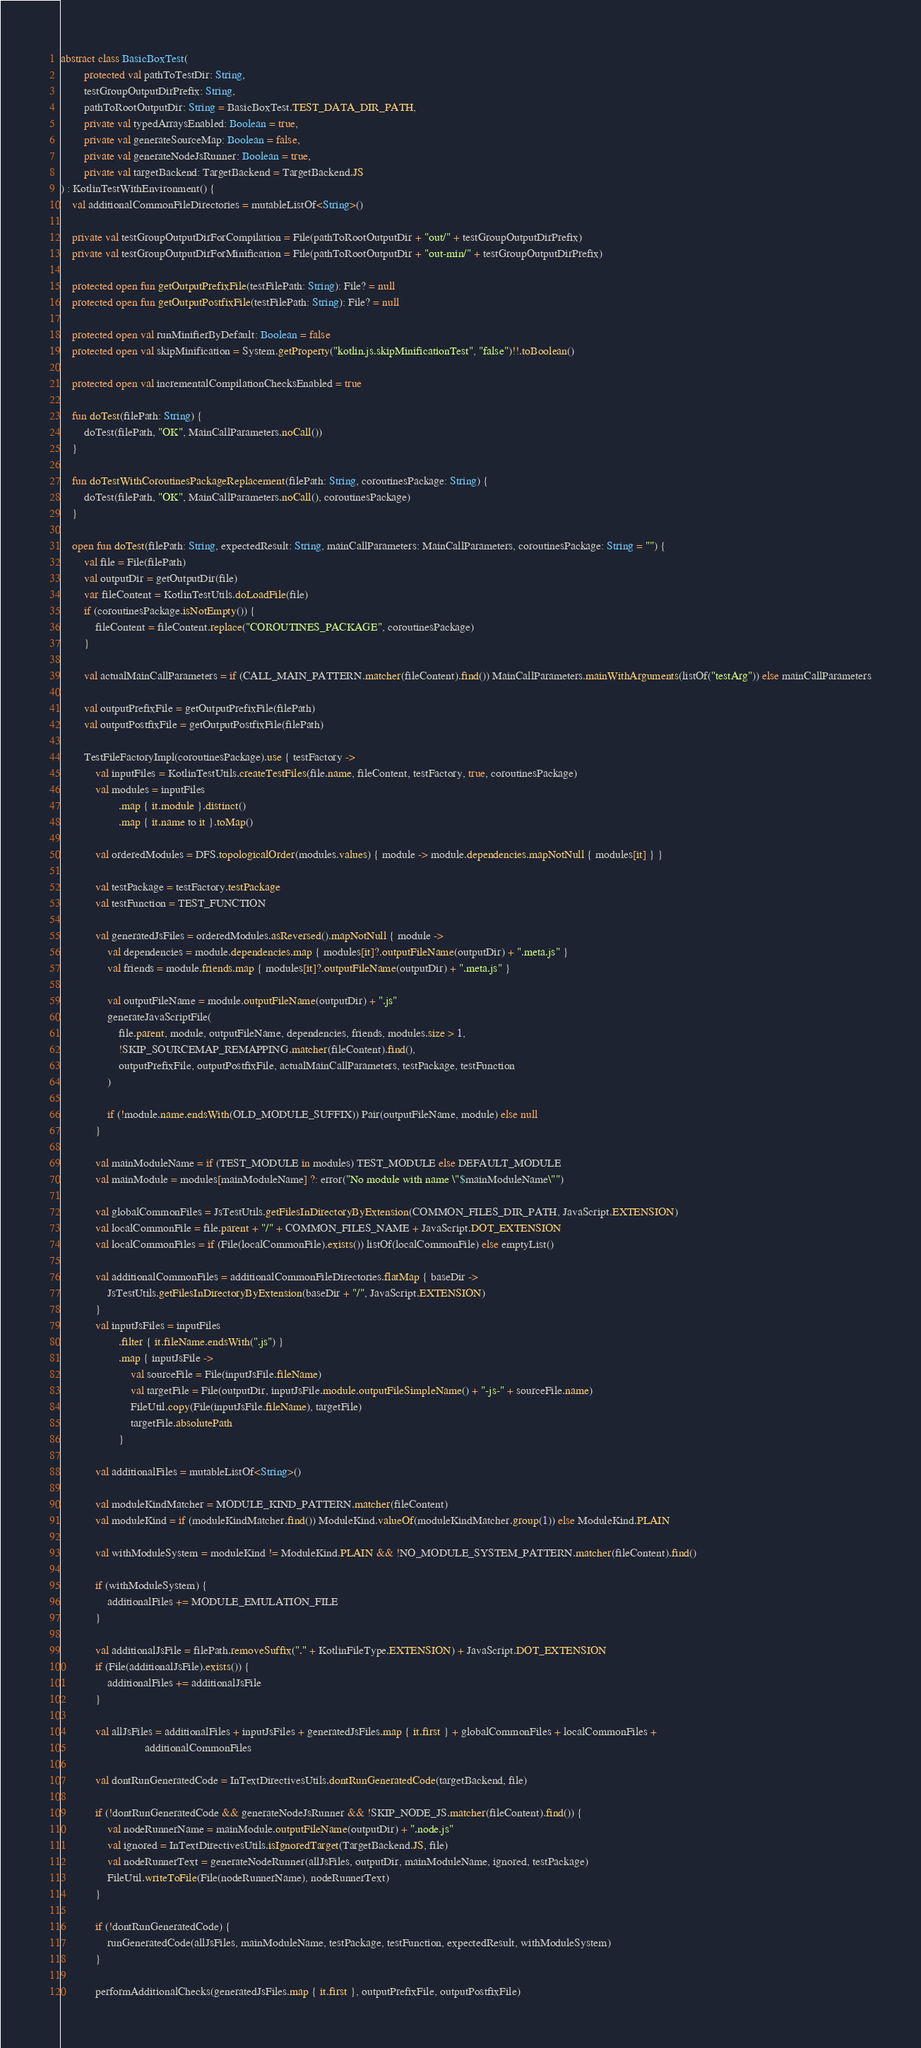Convert code to text. <code><loc_0><loc_0><loc_500><loc_500><_Kotlin_>abstract class BasicBoxTest(
        protected val pathToTestDir: String,
        testGroupOutputDirPrefix: String,
        pathToRootOutputDir: String = BasicBoxTest.TEST_DATA_DIR_PATH,
        private val typedArraysEnabled: Boolean = true,
        private val generateSourceMap: Boolean = false,
        private val generateNodeJsRunner: Boolean = true,
        private val targetBackend: TargetBackend = TargetBackend.JS
) : KotlinTestWithEnvironment() {
    val additionalCommonFileDirectories = mutableListOf<String>()

    private val testGroupOutputDirForCompilation = File(pathToRootOutputDir + "out/" + testGroupOutputDirPrefix)
    private val testGroupOutputDirForMinification = File(pathToRootOutputDir + "out-min/" + testGroupOutputDirPrefix)

    protected open fun getOutputPrefixFile(testFilePath: String): File? = null
    protected open fun getOutputPostfixFile(testFilePath: String): File? = null

    protected open val runMinifierByDefault: Boolean = false
    protected open val skipMinification = System.getProperty("kotlin.js.skipMinificationTest", "false")!!.toBoolean()

    protected open val incrementalCompilationChecksEnabled = true

    fun doTest(filePath: String) {
        doTest(filePath, "OK", MainCallParameters.noCall())
    }

    fun doTestWithCoroutinesPackageReplacement(filePath: String, coroutinesPackage: String) {
        doTest(filePath, "OK", MainCallParameters.noCall(), coroutinesPackage)
    }

    open fun doTest(filePath: String, expectedResult: String, mainCallParameters: MainCallParameters, coroutinesPackage: String = "") {
        val file = File(filePath)
        val outputDir = getOutputDir(file)
        var fileContent = KotlinTestUtils.doLoadFile(file)
        if (coroutinesPackage.isNotEmpty()) {
            fileContent = fileContent.replace("COROUTINES_PACKAGE", coroutinesPackage)
        }

        val actualMainCallParameters = if (CALL_MAIN_PATTERN.matcher(fileContent).find()) MainCallParameters.mainWithArguments(listOf("testArg")) else mainCallParameters

        val outputPrefixFile = getOutputPrefixFile(filePath)
        val outputPostfixFile = getOutputPostfixFile(filePath)

        TestFileFactoryImpl(coroutinesPackage).use { testFactory ->
            val inputFiles = KotlinTestUtils.createTestFiles(file.name, fileContent, testFactory, true, coroutinesPackage)
            val modules = inputFiles
                    .map { it.module }.distinct()
                    .map { it.name to it }.toMap()

            val orderedModules = DFS.topologicalOrder(modules.values) { module -> module.dependencies.mapNotNull { modules[it] } }

            val testPackage = testFactory.testPackage
            val testFunction = TEST_FUNCTION

            val generatedJsFiles = orderedModules.asReversed().mapNotNull { module ->
                val dependencies = module.dependencies.map { modules[it]?.outputFileName(outputDir) + ".meta.js" }
                val friends = module.friends.map { modules[it]?.outputFileName(outputDir) + ".meta.js" }

                val outputFileName = module.outputFileName(outputDir) + ".js"
                generateJavaScriptFile(
                    file.parent, module, outputFileName, dependencies, friends, modules.size > 1,
                    !SKIP_SOURCEMAP_REMAPPING.matcher(fileContent).find(),
                    outputPrefixFile, outputPostfixFile, actualMainCallParameters, testPackage, testFunction
                )

                if (!module.name.endsWith(OLD_MODULE_SUFFIX)) Pair(outputFileName, module) else null
            }

            val mainModuleName = if (TEST_MODULE in modules) TEST_MODULE else DEFAULT_MODULE
            val mainModule = modules[mainModuleName] ?: error("No module with name \"$mainModuleName\"")

            val globalCommonFiles = JsTestUtils.getFilesInDirectoryByExtension(COMMON_FILES_DIR_PATH, JavaScript.EXTENSION)
            val localCommonFile = file.parent + "/" + COMMON_FILES_NAME + JavaScript.DOT_EXTENSION
            val localCommonFiles = if (File(localCommonFile).exists()) listOf(localCommonFile) else emptyList()

            val additionalCommonFiles = additionalCommonFileDirectories.flatMap { baseDir ->
                JsTestUtils.getFilesInDirectoryByExtension(baseDir + "/", JavaScript.EXTENSION)
            }
            val inputJsFiles = inputFiles
                    .filter { it.fileName.endsWith(".js") }
                    .map { inputJsFile ->
                        val sourceFile = File(inputJsFile.fileName)
                        val targetFile = File(outputDir, inputJsFile.module.outputFileSimpleName() + "-js-" + sourceFile.name)
                        FileUtil.copy(File(inputJsFile.fileName), targetFile)
                        targetFile.absolutePath
                    }

            val additionalFiles = mutableListOf<String>()

            val moduleKindMatcher = MODULE_KIND_PATTERN.matcher(fileContent)
            val moduleKind = if (moduleKindMatcher.find()) ModuleKind.valueOf(moduleKindMatcher.group(1)) else ModuleKind.PLAIN

            val withModuleSystem = moduleKind != ModuleKind.PLAIN && !NO_MODULE_SYSTEM_PATTERN.matcher(fileContent).find()

            if (withModuleSystem) {
                additionalFiles += MODULE_EMULATION_FILE
            }

            val additionalJsFile = filePath.removeSuffix("." + KotlinFileType.EXTENSION) + JavaScript.DOT_EXTENSION
            if (File(additionalJsFile).exists()) {
                additionalFiles += additionalJsFile
            }

            val allJsFiles = additionalFiles + inputJsFiles + generatedJsFiles.map { it.first } + globalCommonFiles + localCommonFiles +
                             additionalCommonFiles

            val dontRunGeneratedCode = InTextDirectivesUtils.dontRunGeneratedCode(targetBackend, file)

            if (!dontRunGeneratedCode && generateNodeJsRunner && !SKIP_NODE_JS.matcher(fileContent).find()) {
                val nodeRunnerName = mainModule.outputFileName(outputDir) + ".node.js"
                val ignored = InTextDirectivesUtils.isIgnoredTarget(TargetBackend.JS, file)
                val nodeRunnerText = generateNodeRunner(allJsFiles, outputDir, mainModuleName, ignored, testPackage)
                FileUtil.writeToFile(File(nodeRunnerName), nodeRunnerText)
            }

            if (!dontRunGeneratedCode) {
                runGeneratedCode(allJsFiles, mainModuleName, testPackage, testFunction, expectedResult, withModuleSystem)
            }

            performAdditionalChecks(generatedJsFiles.map { it.first }, outputPrefixFile, outputPostfixFile)
</code> 